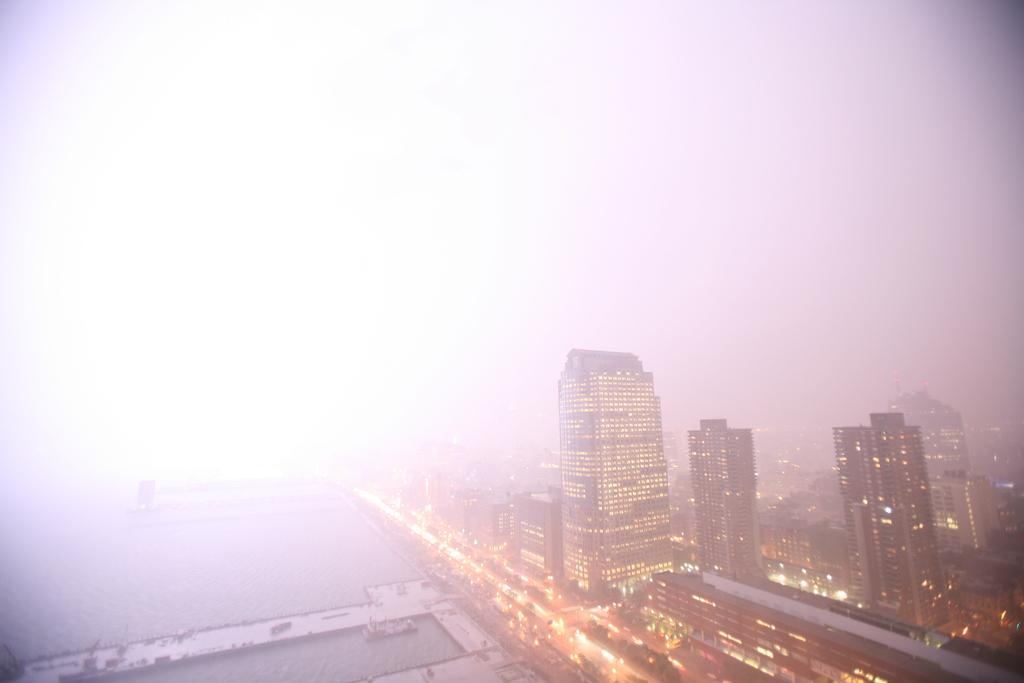What type of structures are present in the image? There are buildings and skyscrapers in the image. What can be seen on the left side of the image? There is water visible on the left side of the image. What is visible at the top of the image? The sky is visible at the top of the image. How would you describe the background of the image? The background appears blurred, possibly resembling smoke. How many fairies are sitting on the vase in the image? There are no fairies or vases present in the image. 